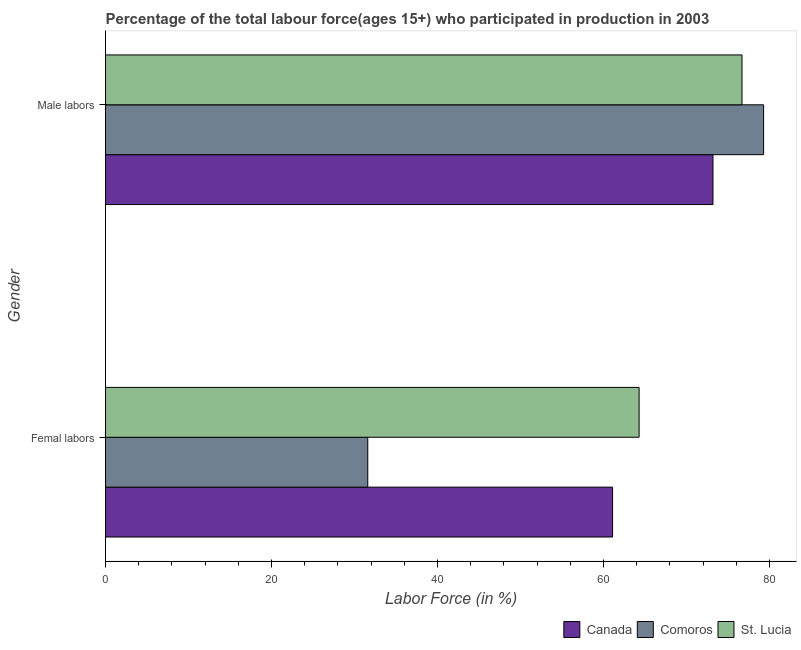Are the number of bars per tick equal to the number of legend labels?
Make the answer very short. Yes. Are the number of bars on each tick of the Y-axis equal?
Make the answer very short. Yes. How many bars are there on the 2nd tick from the top?
Keep it short and to the point. 3. How many bars are there on the 2nd tick from the bottom?
Provide a short and direct response. 3. What is the label of the 1st group of bars from the top?
Your answer should be compact. Male labors. What is the percentage of male labour force in St. Lucia?
Your answer should be compact. 76.7. Across all countries, what is the maximum percentage of male labour force?
Make the answer very short. 79.3. Across all countries, what is the minimum percentage of male labour force?
Provide a succinct answer. 73.2. In which country was the percentage of male labour force maximum?
Your response must be concise. Comoros. What is the total percentage of male labour force in the graph?
Offer a terse response. 229.2. What is the difference between the percentage of female labor force in Canada and that in Comoros?
Offer a terse response. 29.5. What is the difference between the percentage of male labour force in Comoros and the percentage of female labor force in St. Lucia?
Give a very brief answer. 15. What is the average percentage of male labour force per country?
Your answer should be compact. 76.4. What is the difference between the percentage of male labour force and percentage of female labor force in St. Lucia?
Make the answer very short. 12.4. What is the ratio of the percentage of female labor force in St. Lucia to that in Canada?
Make the answer very short. 1.05. Is the percentage of male labour force in Canada less than that in Comoros?
Offer a terse response. Yes. In how many countries, is the percentage of male labour force greater than the average percentage of male labour force taken over all countries?
Keep it short and to the point. 2. What does the 2nd bar from the top in Male labors represents?
Your response must be concise. Comoros. How many countries are there in the graph?
Offer a very short reply. 3. What is the difference between two consecutive major ticks on the X-axis?
Your answer should be very brief. 20. Are the values on the major ticks of X-axis written in scientific E-notation?
Ensure brevity in your answer.  No. Does the graph contain any zero values?
Give a very brief answer. No. Does the graph contain grids?
Offer a very short reply. No. How many legend labels are there?
Ensure brevity in your answer.  3. How are the legend labels stacked?
Your answer should be compact. Horizontal. What is the title of the graph?
Offer a very short reply. Percentage of the total labour force(ages 15+) who participated in production in 2003. What is the Labor Force (in %) in Canada in Femal labors?
Ensure brevity in your answer.  61.1. What is the Labor Force (in %) of Comoros in Femal labors?
Offer a terse response. 31.6. What is the Labor Force (in %) in St. Lucia in Femal labors?
Make the answer very short. 64.3. What is the Labor Force (in %) of Canada in Male labors?
Provide a succinct answer. 73.2. What is the Labor Force (in %) of Comoros in Male labors?
Offer a very short reply. 79.3. What is the Labor Force (in %) of St. Lucia in Male labors?
Make the answer very short. 76.7. Across all Gender, what is the maximum Labor Force (in %) of Canada?
Ensure brevity in your answer.  73.2. Across all Gender, what is the maximum Labor Force (in %) in Comoros?
Provide a short and direct response. 79.3. Across all Gender, what is the maximum Labor Force (in %) in St. Lucia?
Give a very brief answer. 76.7. Across all Gender, what is the minimum Labor Force (in %) in Canada?
Keep it short and to the point. 61.1. Across all Gender, what is the minimum Labor Force (in %) in Comoros?
Provide a short and direct response. 31.6. Across all Gender, what is the minimum Labor Force (in %) of St. Lucia?
Offer a very short reply. 64.3. What is the total Labor Force (in %) of Canada in the graph?
Provide a succinct answer. 134.3. What is the total Labor Force (in %) of Comoros in the graph?
Make the answer very short. 110.9. What is the total Labor Force (in %) in St. Lucia in the graph?
Provide a short and direct response. 141. What is the difference between the Labor Force (in %) of Canada in Femal labors and that in Male labors?
Ensure brevity in your answer.  -12.1. What is the difference between the Labor Force (in %) of Comoros in Femal labors and that in Male labors?
Your response must be concise. -47.7. What is the difference between the Labor Force (in %) of Canada in Femal labors and the Labor Force (in %) of Comoros in Male labors?
Ensure brevity in your answer.  -18.2. What is the difference between the Labor Force (in %) in Canada in Femal labors and the Labor Force (in %) in St. Lucia in Male labors?
Provide a succinct answer. -15.6. What is the difference between the Labor Force (in %) in Comoros in Femal labors and the Labor Force (in %) in St. Lucia in Male labors?
Provide a succinct answer. -45.1. What is the average Labor Force (in %) in Canada per Gender?
Give a very brief answer. 67.15. What is the average Labor Force (in %) of Comoros per Gender?
Ensure brevity in your answer.  55.45. What is the average Labor Force (in %) in St. Lucia per Gender?
Ensure brevity in your answer.  70.5. What is the difference between the Labor Force (in %) in Canada and Labor Force (in %) in Comoros in Femal labors?
Provide a short and direct response. 29.5. What is the difference between the Labor Force (in %) of Canada and Labor Force (in %) of St. Lucia in Femal labors?
Your answer should be compact. -3.2. What is the difference between the Labor Force (in %) of Comoros and Labor Force (in %) of St. Lucia in Femal labors?
Offer a terse response. -32.7. What is the difference between the Labor Force (in %) in Canada and Labor Force (in %) in St. Lucia in Male labors?
Give a very brief answer. -3.5. What is the difference between the Labor Force (in %) in Comoros and Labor Force (in %) in St. Lucia in Male labors?
Your answer should be very brief. 2.6. What is the ratio of the Labor Force (in %) of Canada in Femal labors to that in Male labors?
Your answer should be very brief. 0.83. What is the ratio of the Labor Force (in %) of Comoros in Femal labors to that in Male labors?
Keep it short and to the point. 0.4. What is the ratio of the Labor Force (in %) of St. Lucia in Femal labors to that in Male labors?
Ensure brevity in your answer.  0.84. What is the difference between the highest and the second highest Labor Force (in %) in Comoros?
Give a very brief answer. 47.7. What is the difference between the highest and the second highest Labor Force (in %) in St. Lucia?
Give a very brief answer. 12.4. What is the difference between the highest and the lowest Labor Force (in %) in Comoros?
Offer a very short reply. 47.7. What is the difference between the highest and the lowest Labor Force (in %) in St. Lucia?
Keep it short and to the point. 12.4. 